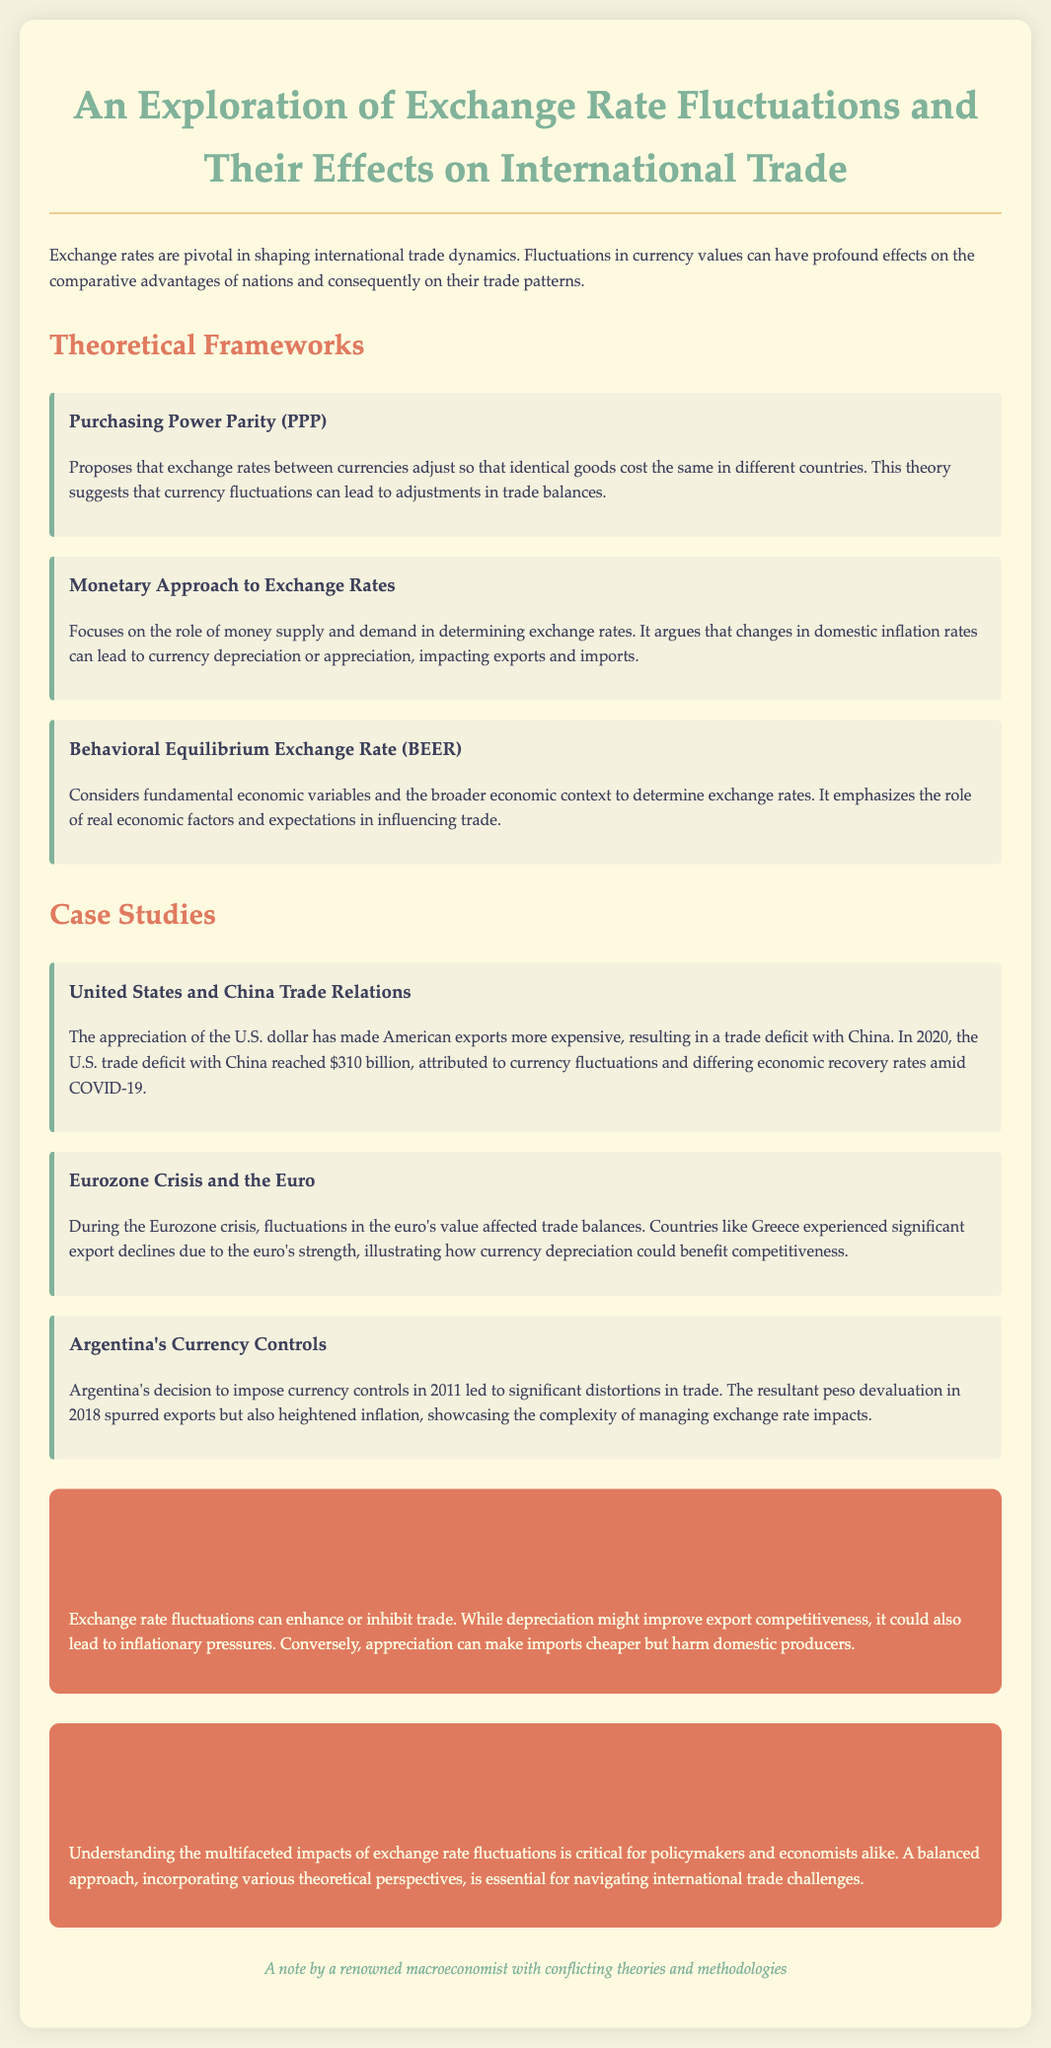What is the title of the document? The title of the document is presented at the top and indicates the main subject.
Answer: An Exploration of Exchange Rate Fluctuations and Their Effects on International Trade What year did the U.S. trade deficit with China reach $310 billion? The document mentions the year of the trade deficit alongside the context of the U.S. dollar appreciation.
Answer: 2020 What economic situation influenced Argentina's currency controls? The document provides a specific event related to Argentina that illustrates its economic situation.
Answer: Peso devaluation Which theory suggests identical goods should cost the same in different countries? The document names the theory outlining the concept of price parity in relation to currency.
Answer: Purchasing Power Parity What is a potential effect of currency depreciation according to the impact analysis? The impact analysis discusses how currency fluctuations can influence various aspects of trade.
Answer: Improve export competitiveness How did the Eurozone crisis affect Greece's trade? The case study on the Eurozone crisis discusses its impact on trade for specific countries.
Answer: Significant export declines Which approach focuses on the role of money supply and demand? The document outlines various theoretical approaches and names one that emphasizes monetary factors.
Answer: Monetary Approach to Exchange Rates What color is used for the impact analysis section? The document describes the color scheme used in different sections for visual organization.
Answer: E07A5F 